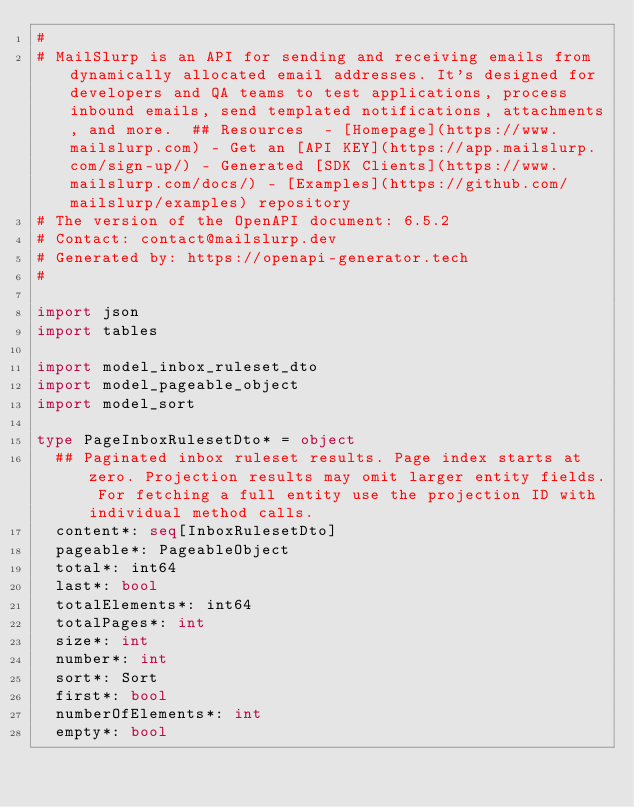Convert code to text. <code><loc_0><loc_0><loc_500><loc_500><_Nim_># 
# MailSlurp is an API for sending and receiving emails from dynamically allocated email addresses. It's designed for developers and QA teams to test applications, process inbound emails, send templated notifications, attachments, and more.  ## Resources  - [Homepage](https://www.mailslurp.com) - Get an [API KEY](https://app.mailslurp.com/sign-up/) - Generated [SDK Clients](https://www.mailslurp.com/docs/) - [Examples](https://github.com/mailslurp/examples) repository
# The version of the OpenAPI document: 6.5.2
# Contact: contact@mailslurp.dev
# Generated by: https://openapi-generator.tech
#

import json
import tables

import model_inbox_ruleset_dto
import model_pageable_object
import model_sort

type PageInboxRulesetDto* = object
  ## Paginated inbox ruleset results. Page index starts at zero. Projection results may omit larger entity fields. For fetching a full entity use the projection ID with individual method calls.
  content*: seq[InboxRulesetDto]
  pageable*: PageableObject
  total*: int64
  last*: bool
  totalElements*: int64
  totalPages*: int
  size*: int
  number*: int
  sort*: Sort
  first*: bool
  numberOfElements*: int
  empty*: bool
</code> 